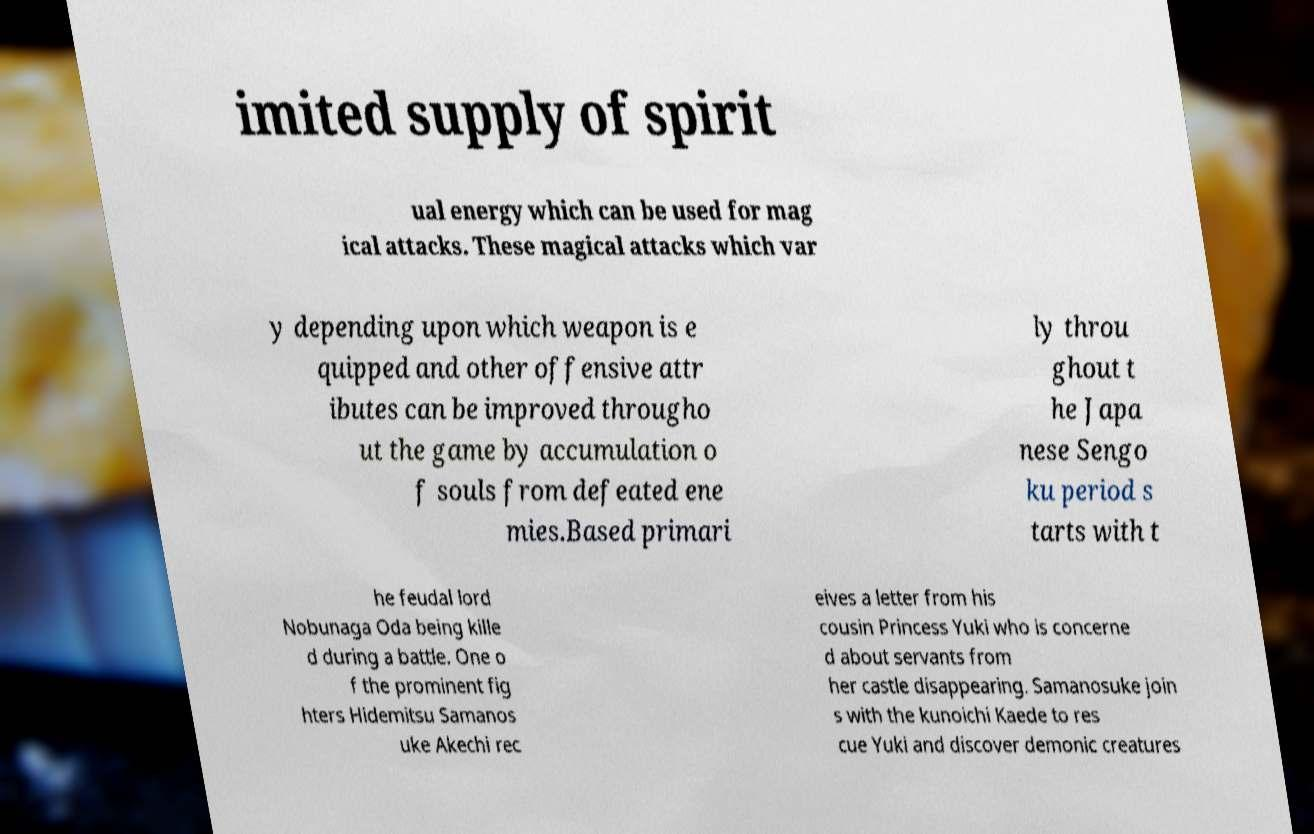There's text embedded in this image that I need extracted. Can you transcribe it verbatim? imited supply of spirit ual energy which can be used for mag ical attacks. These magical attacks which var y depending upon which weapon is e quipped and other offensive attr ibutes can be improved througho ut the game by accumulation o f souls from defeated ene mies.Based primari ly throu ghout t he Japa nese Sengo ku period s tarts with t he feudal lord Nobunaga Oda being kille d during a battle. One o f the prominent fig hters Hidemitsu Samanos uke Akechi rec eives a letter from his cousin Princess Yuki who is concerne d about servants from her castle disappearing. Samanosuke join s with the kunoichi Kaede to res cue Yuki and discover demonic creatures 